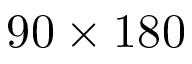Convert formula to latex. <formula><loc_0><loc_0><loc_500><loc_500>9 0 \times 1 8 0</formula> 